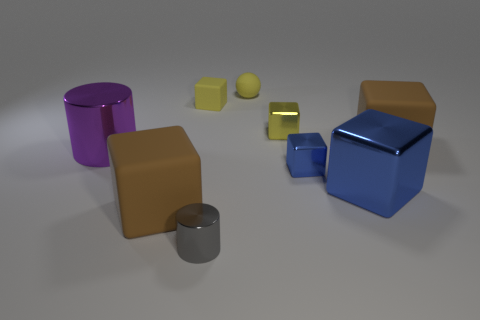Subtract all small matte blocks. How many blocks are left? 5 Subtract all green blocks. Subtract all gray balls. How many blocks are left? 6 Subtract all cubes. How many objects are left? 3 Subtract 2 blue cubes. How many objects are left? 7 Subtract all cylinders. Subtract all cylinders. How many objects are left? 5 Add 1 small yellow metallic things. How many small yellow metallic things are left? 2 Add 3 small matte balls. How many small matte balls exist? 4 